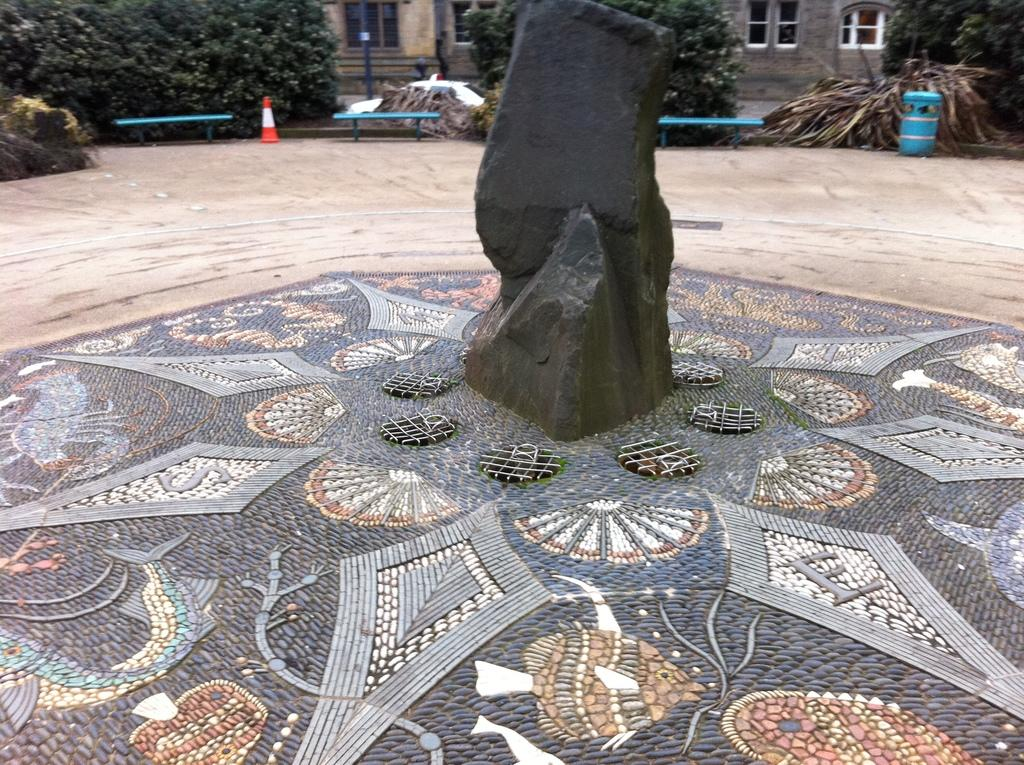What is the main subject of the image? There is a black rock in the image. What can be seen in the background of the image? There are buildings, windows, stairs, trees, and other objects visible in the background. Can you describe the traffic cone in the image? There is a traffic cone in the background of the image. What type of crack can be seen in the image? There is no crack present in the image. Is there an arch visible in the image? There is no arch present in the image. 